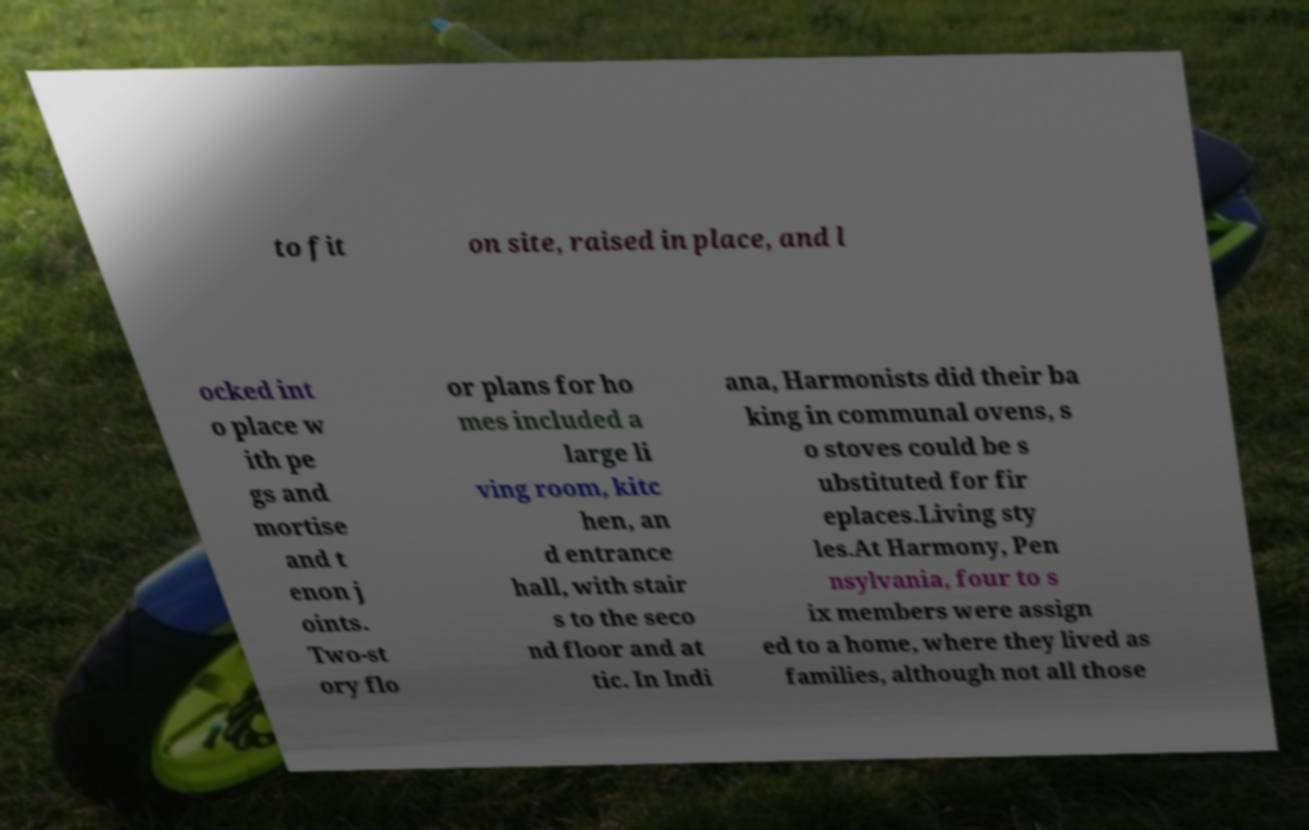Can you accurately transcribe the text from the provided image for me? to fit on site, raised in place, and l ocked int o place w ith pe gs and mortise and t enon j oints. Two-st ory flo or plans for ho mes included a large li ving room, kitc hen, an d entrance hall, with stair s to the seco nd floor and at tic. In Indi ana, Harmonists did their ba king in communal ovens, s o stoves could be s ubstituted for fir eplaces.Living sty les.At Harmony, Pen nsylvania, four to s ix members were assign ed to a home, where they lived as families, although not all those 